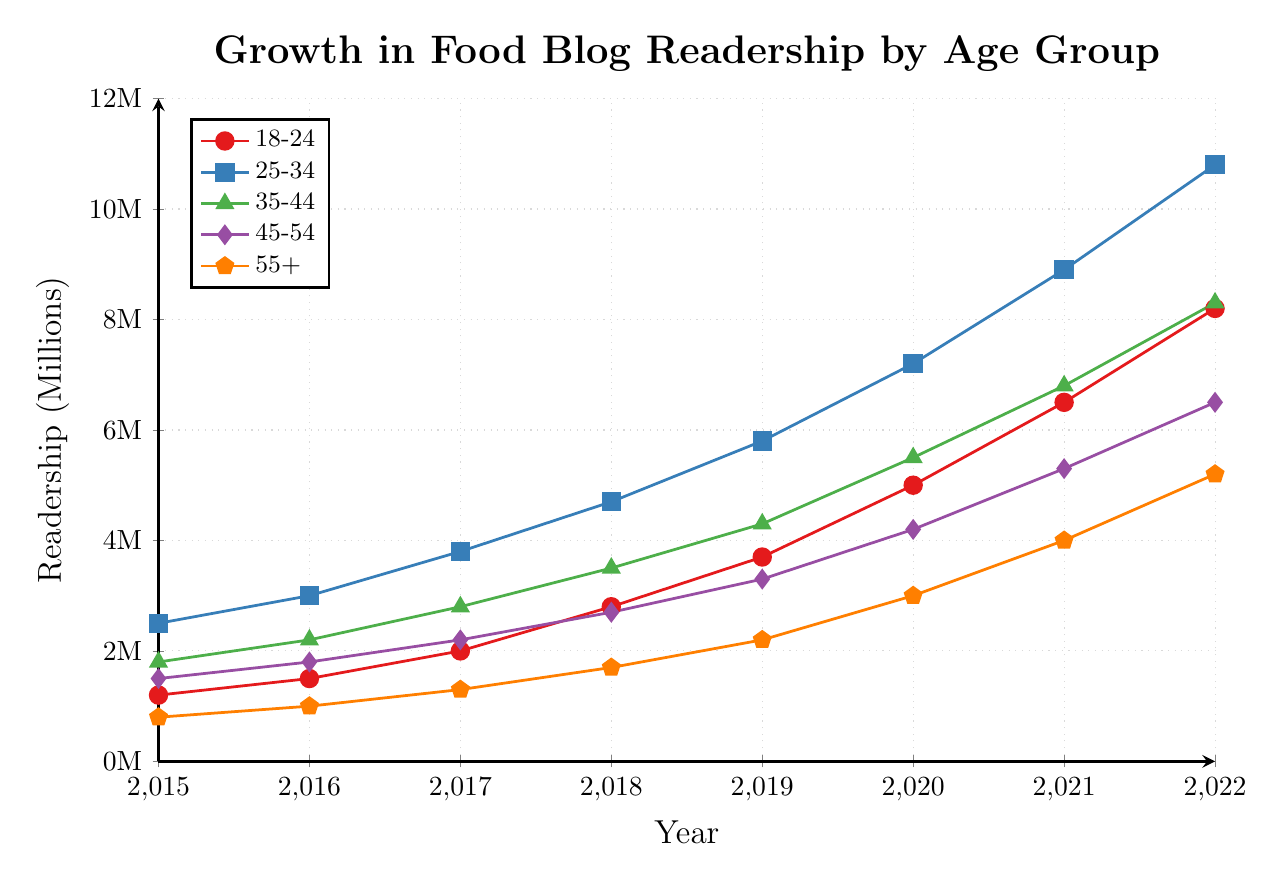Which age group had the highest readership in 2022? The plot shows different age groups represented with different colors and symbols. In 2022, the 25-34 age group (blue squares) had the highest value on the y-axis.
Answer: 25-34 Which age group showed the largest increase in readership between 2015 and 2022? By comparing the starting and ending values for each age group: 18-24 increased by 7 million, 25-34 by 8.3 million, 35-44 by 6.5 million, 45-54 by 5 million, and 55+ by 4.4 million. The 25-34 age group showed the largest increase.
Answer: 25-34 What was the readership for the 55+ age group in 2018 and how did it compare to the 18-24 age group in the same year? In 2018, the 55+ age group (orange pentagons) had 1.7 million readers, while the 18-24 age group (red circles) had 2.8 million. 18-24 had 1.1 million more readers than 55+.
Answer: 18-24 had 1.1M more How much did the readership of the 35-44 age group grow from 2017 to 2021? In 2017, the 35-44 age group (green triangles) had 2.8 million readers, and in 2021 it had 6.8 million. The difference is 6.8 - 2.8 = 4 million.
Answer: 4 million Which age group had the smallest growth in readership from 2020 to 2022? Comparing growth: 18-24 increased by 3.2 million, 25-34 by 3.6 million, 35-44 by 2.8 million, 45-54 by 2.3 million, and 55+ by 2.2 million. The 55+ age group had the smallest growth.
Answer: 55+ What year did the 18-24 and 35-44 age groups first have the same readership, if any? The plot shows these two age groups never had the same readership in any year.
Answer: Never By how many millions did the readership for the 45-54 age group increase from 2018 to 2019? In 2018, the 45-54 age group (purple diamonds) had 2.7 million readers, and in 2019 it had 3.3 million readers. The increase is 3.3 - 2.7 = 0.6 million.
Answer: 0.6 million Which two age groups had the closest readership numbers in 2017? In 2017, the 18-24 (2 million) and 45-54 (2.2 million) age groups are closest, with a difference of 0.2 million.
Answer: 18-24 and 45-54 What was the difference in readership between the 25-34 and 45-54 age groups in 2020? In 2020, the 25-34 age group (blue squares) had 7.2 million readers and the 45-54 age group (purple diamonds) had 4.2 million. The difference is 7.2 - 4.2 = 3 million.
Answer: 3 million 